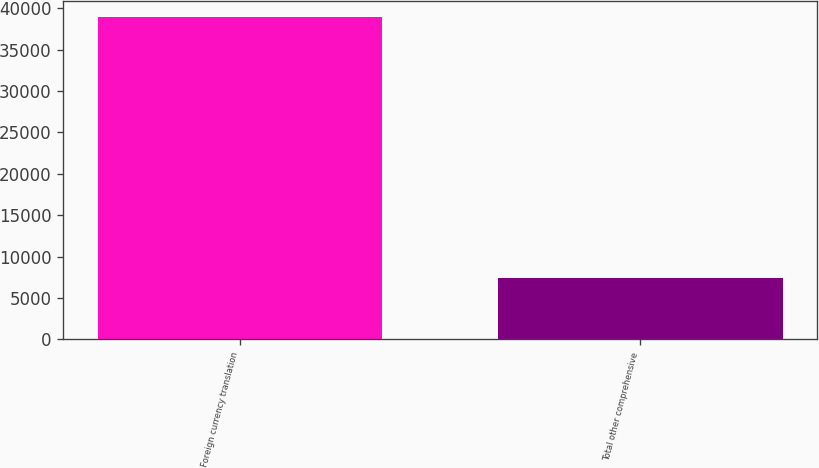<chart> <loc_0><loc_0><loc_500><loc_500><bar_chart><fcel>Foreign currency translation<fcel>Total other comprehensive<nl><fcel>38880<fcel>7396<nl></chart> 